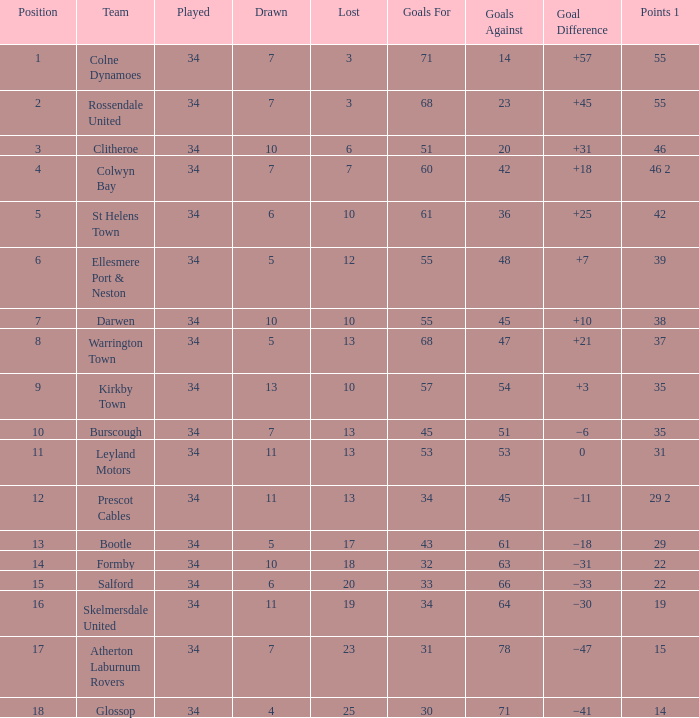Which place has 47 goals against, and a played more than 34? None. 